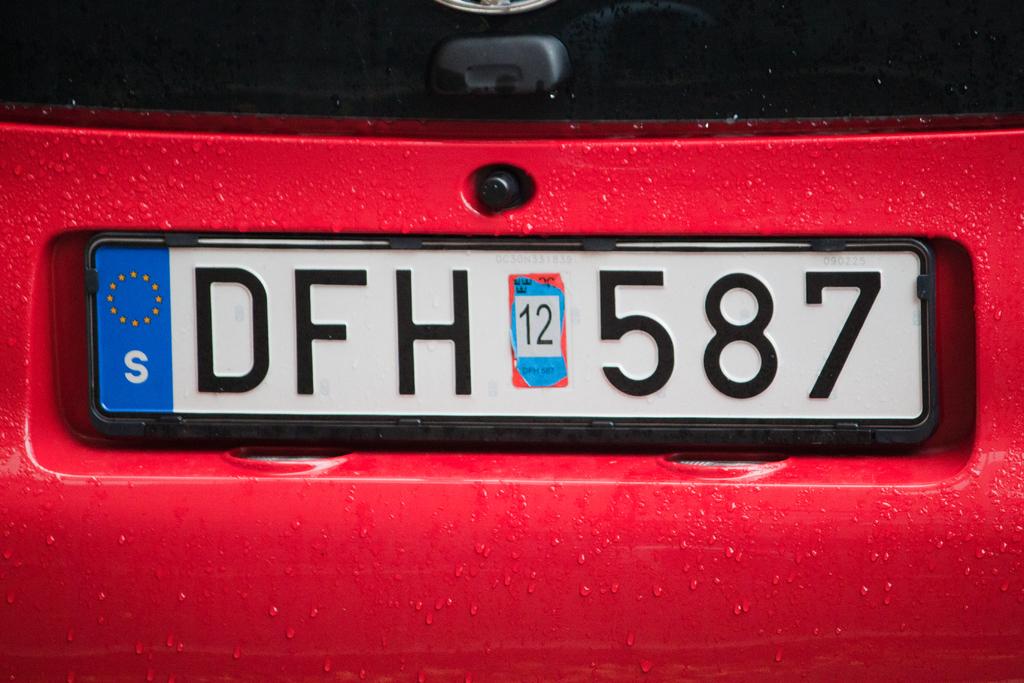What letter is in the blue box?
Offer a terse response. S. 